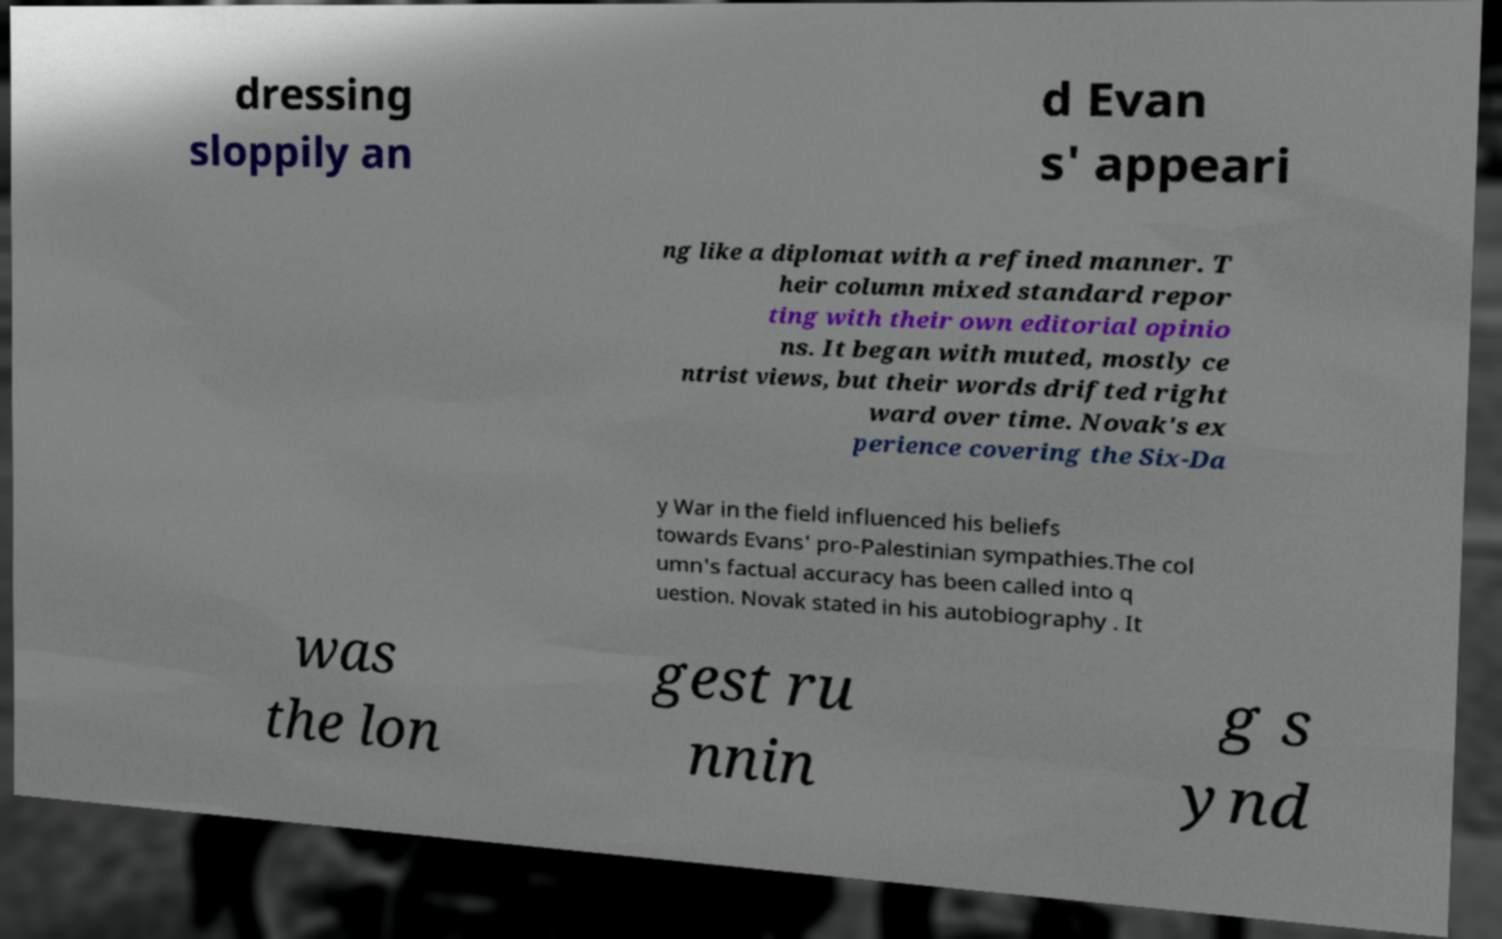Can you read and provide the text displayed in the image?This photo seems to have some interesting text. Can you extract and type it out for me? dressing sloppily an d Evan s' appeari ng like a diplomat with a refined manner. T heir column mixed standard repor ting with their own editorial opinio ns. It began with muted, mostly ce ntrist views, but their words drifted right ward over time. Novak's ex perience covering the Six-Da y War in the field influenced his beliefs towards Evans' pro-Palestinian sympathies.The col umn's factual accuracy has been called into q uestion. Novak stated in his autobiography . It was the lon gest ru nnin g s ynd 